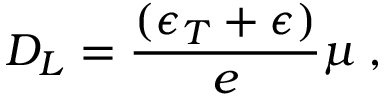<formula> <loc_0><loc_0><loc_500><loc_500>D _ { L } = \frac { ( \epsilon _ { T } + \epsilon ) } { e } \mu \, ,</formula> 